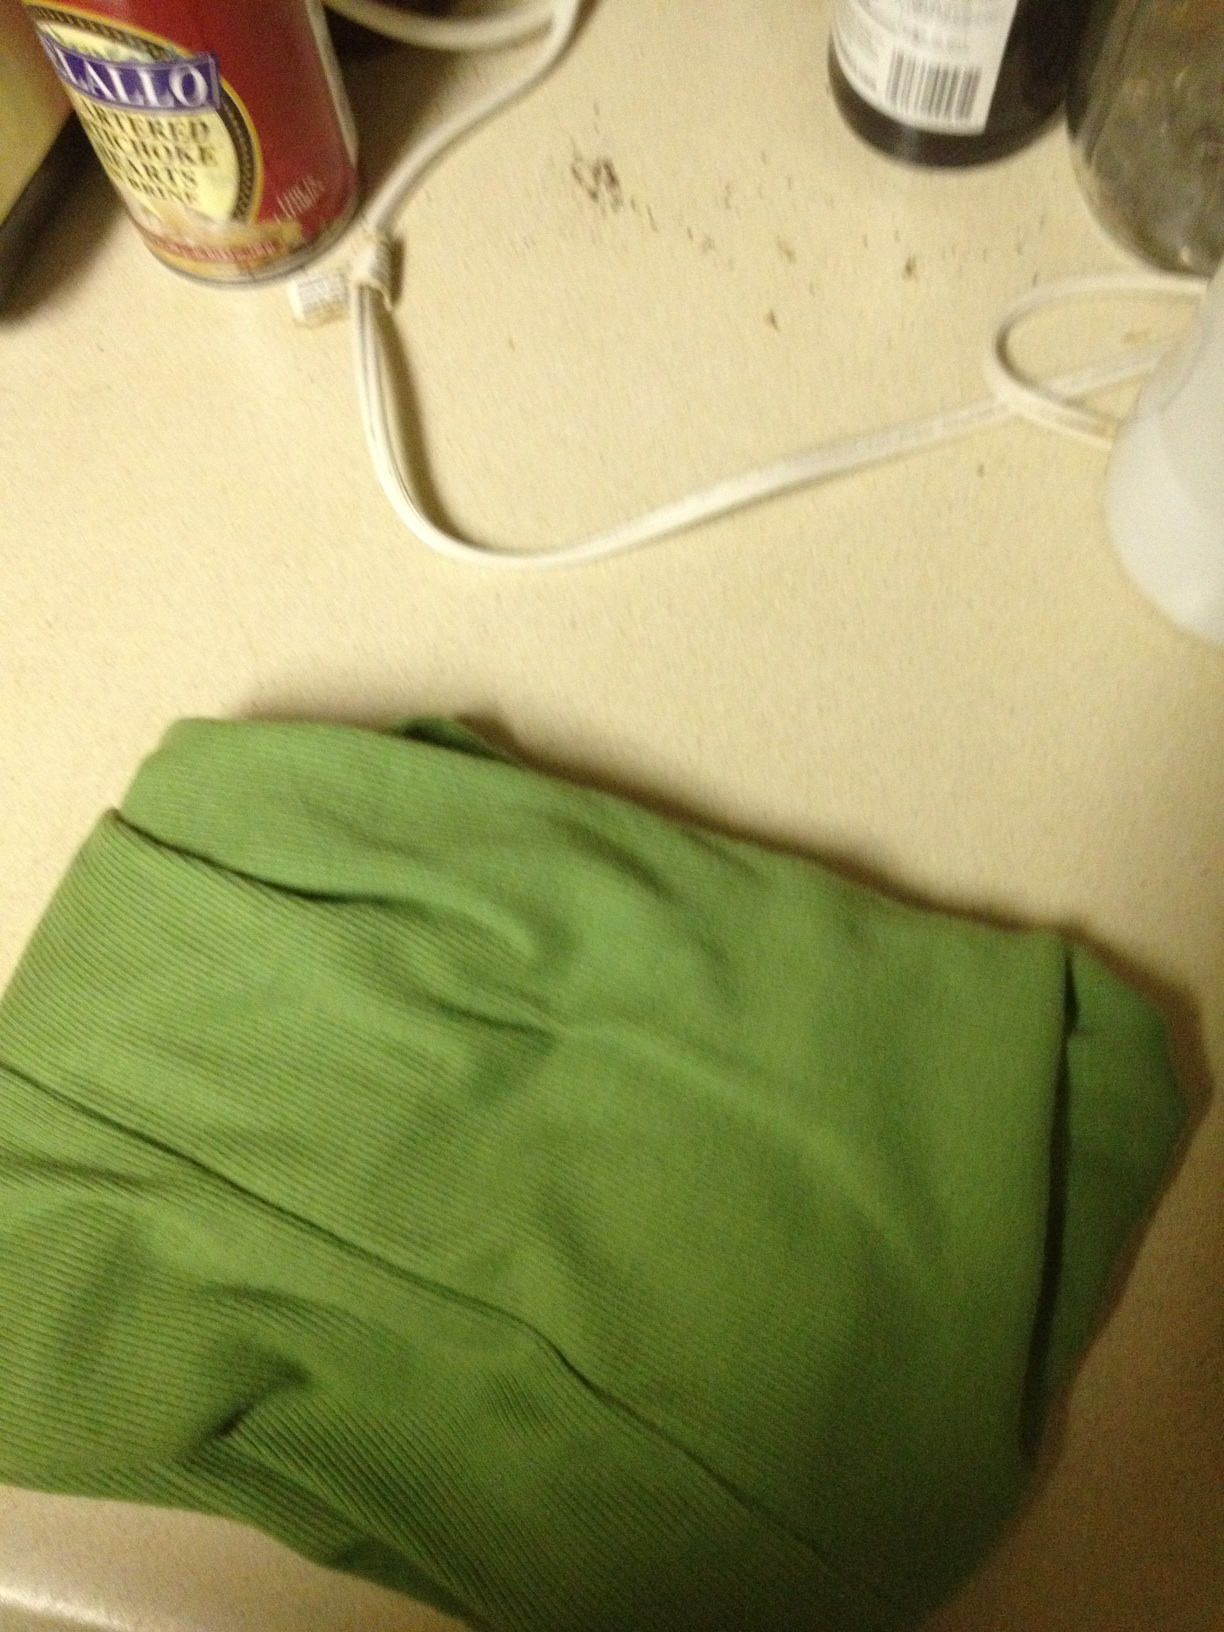What color is this shirt? The shirt in the image is green. 